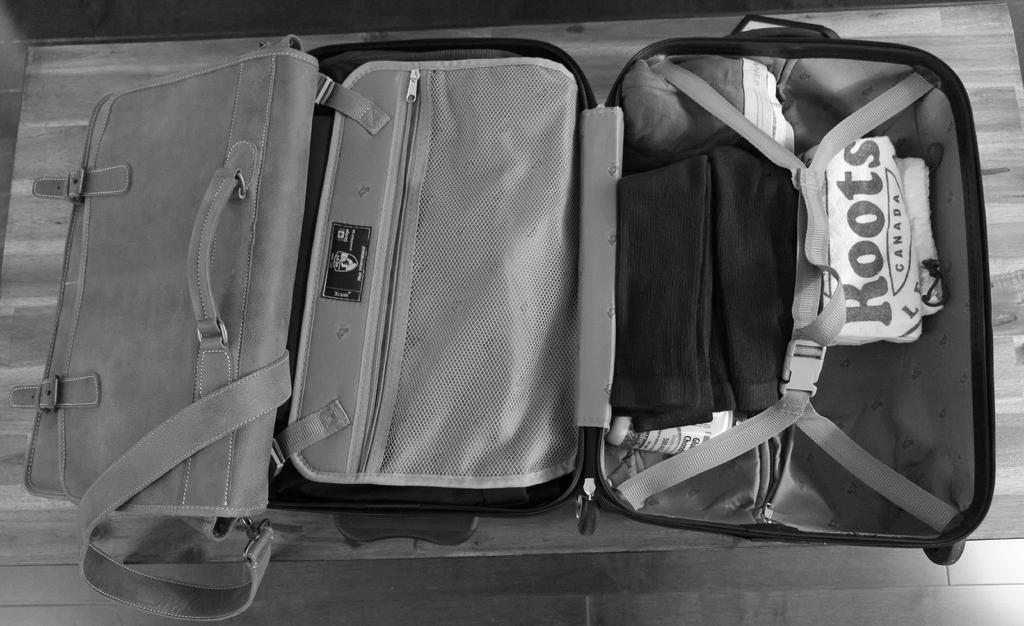What object can be seen in the image? There is a suitcase in the image. What is inside the suitcase? The suitcase contains clothes. What grade of beef is being stored in the suitcase? There is no beef present in the image; the suitcase contains clothes. 